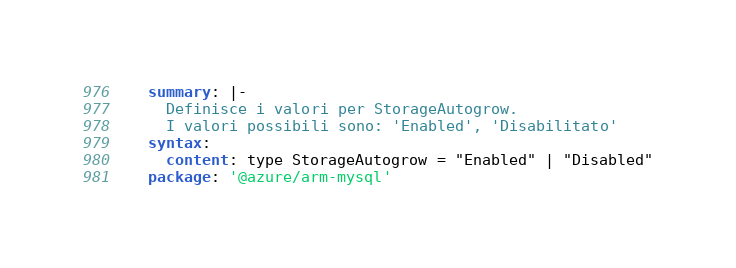<code> <loc_0><loc_0><loc_500><loc_500><_YAML_>    summary: |-
      Definisce i valori per StorageAutogrow.
      I valori possibili sono: 'Enabled', 'Disabilitato'
    syntax:
      content: type StorageAutogrow = "Enabled" | "Disabled"
    package: '@azure/arm-mysql'</code> 